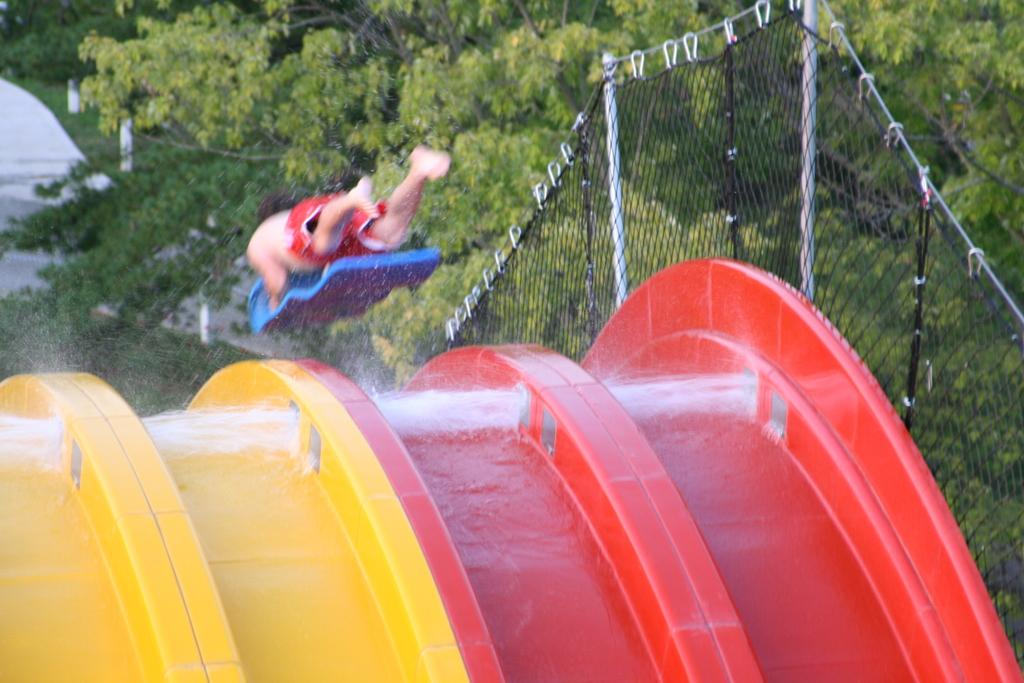What is the person in the image holding? The person is holding an object in the image. Where is the person located in relation to the water slider? The person is above a water slider in the image. What can be seen on the right side of the image? There is a net fence and trees on the right side of the image. Who is the owner of the drug store in the image? There is no drug store present in the image, so it is not possible to determine the owner. 